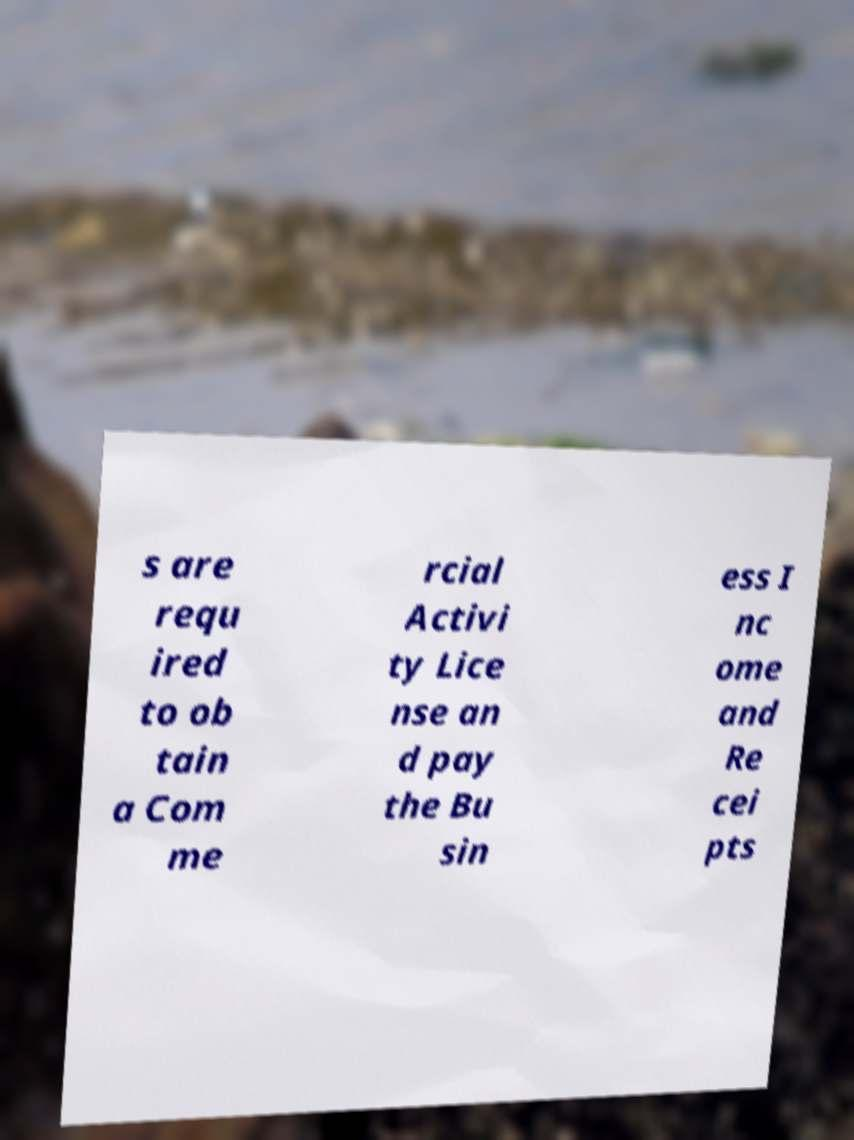Please identify and transcribe the text found in this image. s are requ ired to ob tain a Com me rcial Activi ty Lice nse an d pay the Bu sin ess I nc ome and Re cei pts 